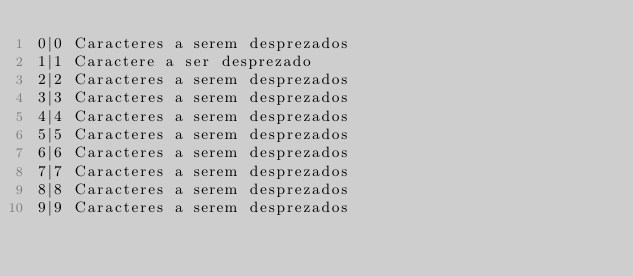<code> <loc_0><loc_0><loc_500><loc_500><_SQL_>0|0 Caracteres a serem desprezados
1|1 Caractere a ser desprezado
2|2 Caracteres a serem desprezados
3|3 Caracteres a serem desprezados
4|4 Caracteres a serem desprezados
5|5 Caracteres a serem desprezados
6|6 Caracteres a serem desprezados
7|7 Caracteres a serem desprezados
8|8 Caracteres a serem desprezados
9|9 Caracteres a serem desprezados
</code> 